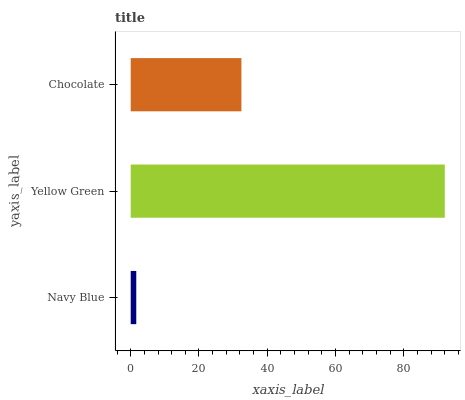Is Navy Blue the minimum?
Answer yes or no. Yes. Is Yellow Green the maximum?
Answer yes or no. Yes. Is Chocolate the minimum?
Answer yes or no. No. Is Chocolate the maximum?
Answer yes or no. No. Is Yellow Green greater than Chocolate?
Answer yes or no. Yes. Is Chocolate less than Yellow Green?
Answer yes or no. Yes. Is Chocolate greater than Yellow Green?
Answer yes or no. No. Is Yellow Green less than Chocolate?
Answer yes or no. No. Is Chocolate the high median?
Answer yes or no. Yes. Is Chocolate the low median?
Answer yes or no. Yes. Is Navy Blue the high median?
Answer yes or no. No. Is Navy Blue the low median?
Answer yes or no. No. 